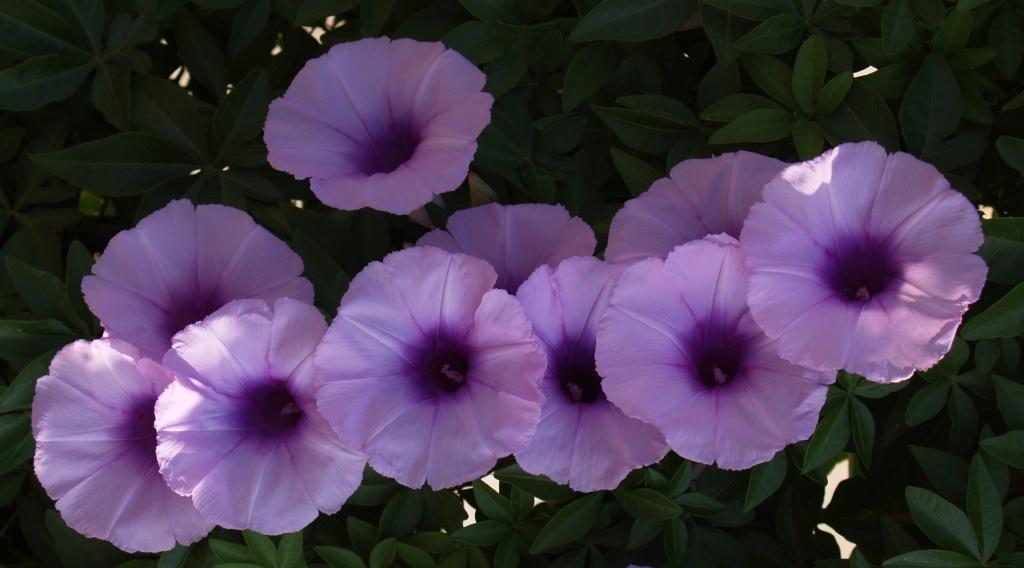What is present in the image? There is a plant in the image. What can be observed about the plant? The plant has flowers. What type of credit can be seen on the plant's leaves in the image? There is no credit present on the plant's leaves in the image. 